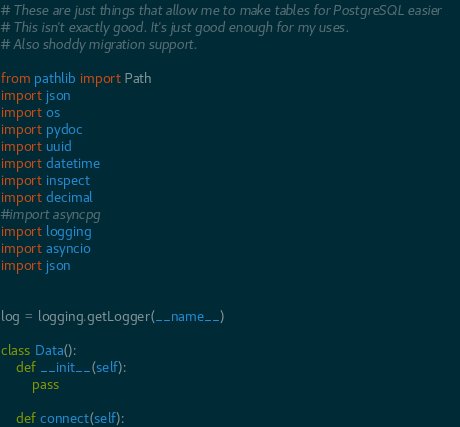Convert code to text. <code><loc_0><loc_0><loc_500><loc_500><_Python_># These are just things that allow me to make tables for PostgreSQL easier
# This isn't exactly good. It's just good enough for my uses.
# Also shoddy migration support.

from pathlib import Path
import json
import os
import pydoc
import uuid
import datetime
import inspect
import decimal
#import asyncpg
import logging
import asyncio
import json


log = logging.getLogger(__name__)

class Data():
    def __init__(self):
        pass

    def connect(self):</code> 